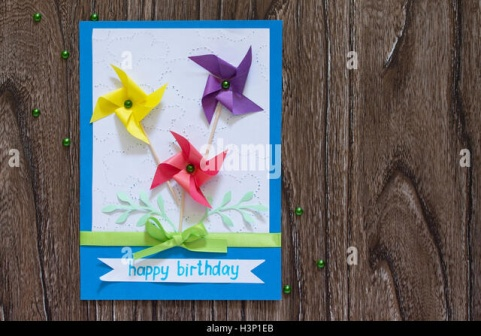Describe the following image. The image showcases a vibrant, celebratory birthday card set against a rustic wooden surface. The card features a predominantly blue border, with a white center elegantly inscribed with the text ‘happy birthday’. Adding to the festive feel are three colorful pinwheels: one yellow, one red, and one purple, each attached to a small green bead in the center. At the bottom of the card, a soft green ribbon further enhances the celebratory theme, accompanied by a sprinkling of small green beads scattered on the wooden background. This cheerful arrangement exudes a joyful and lively atmosphere, perfect for a birthday celebration. 